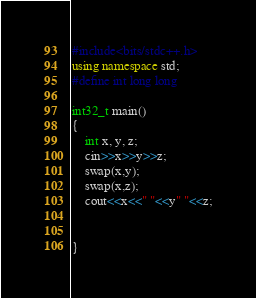<code> <loc_0><loc_0><loc_500><loc_500><_C++_>#include<bits/stdc++.h>
using namespace std;
#define int long long

int32_t main()
{
	int x, y, z;
	cin>>x>>y>>z;
	swap(x,y);
	swap(x,z);
	cout<<x<<" "<<y" "<<z;

	
}</code> 